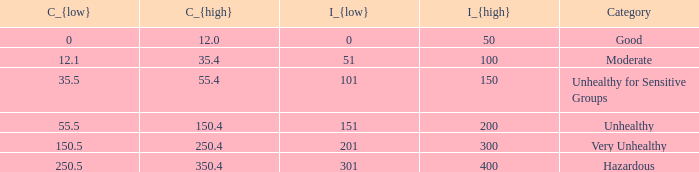What's the i_{high} value when C_{low} is 250.5? 400.0. 